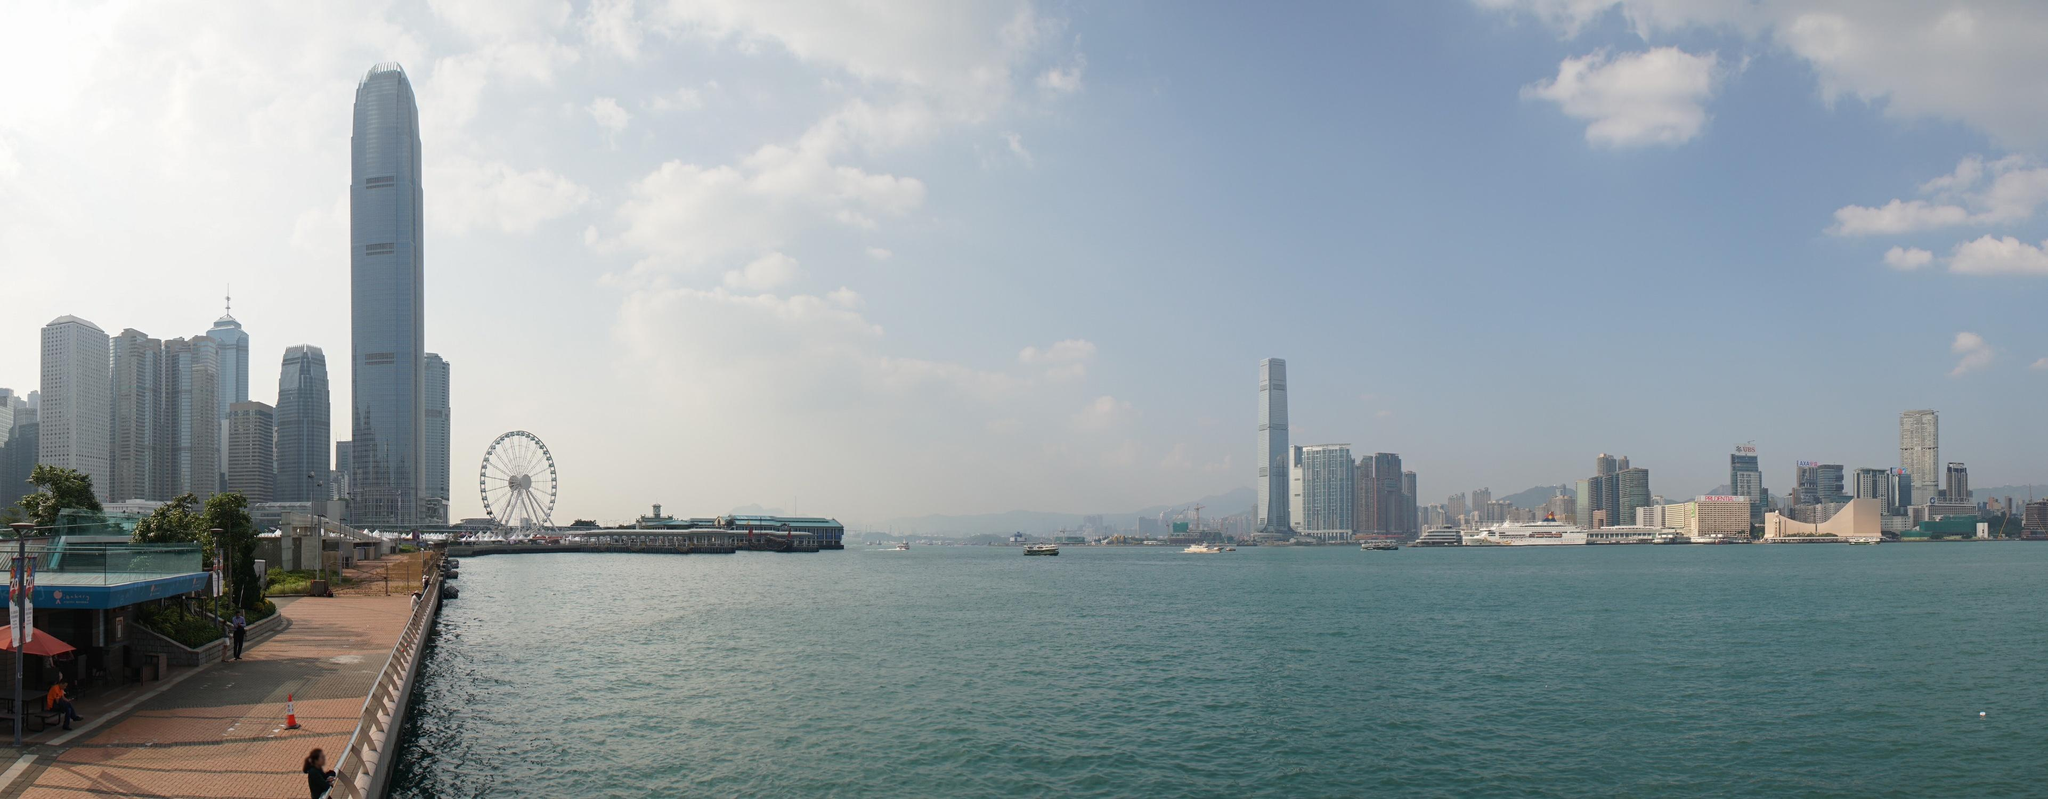What's happening in the scene? This image presents an awe-inspiring vista of the Hong Kong skyline, captured from a vibrant waterfront location. The photograph boasts a low-angle perspective that emphasizes the majestic height of the skyscrapers. The striking buildings, adorned predominantly in shades of white and gray, are complemented by hints of blue and green, symbolizing the city's lively spirit. The calm greenish-blue water of the harbor beautifully contrasts the bustling urban landscape, adding tranquility to the scene. Additionally, a ferris wheel appears to the left, contributing a whimsical touch to the city's ambiance. The bright, clear blue sky spotted with a few fluffy clouds further suggests a sunny, pleasant day. This image showcases Hong Kong's architectural wonders and the dynamic city life flourishing under the glossy skyline, capturing a harmonious blend of urban development and natural beauty. 